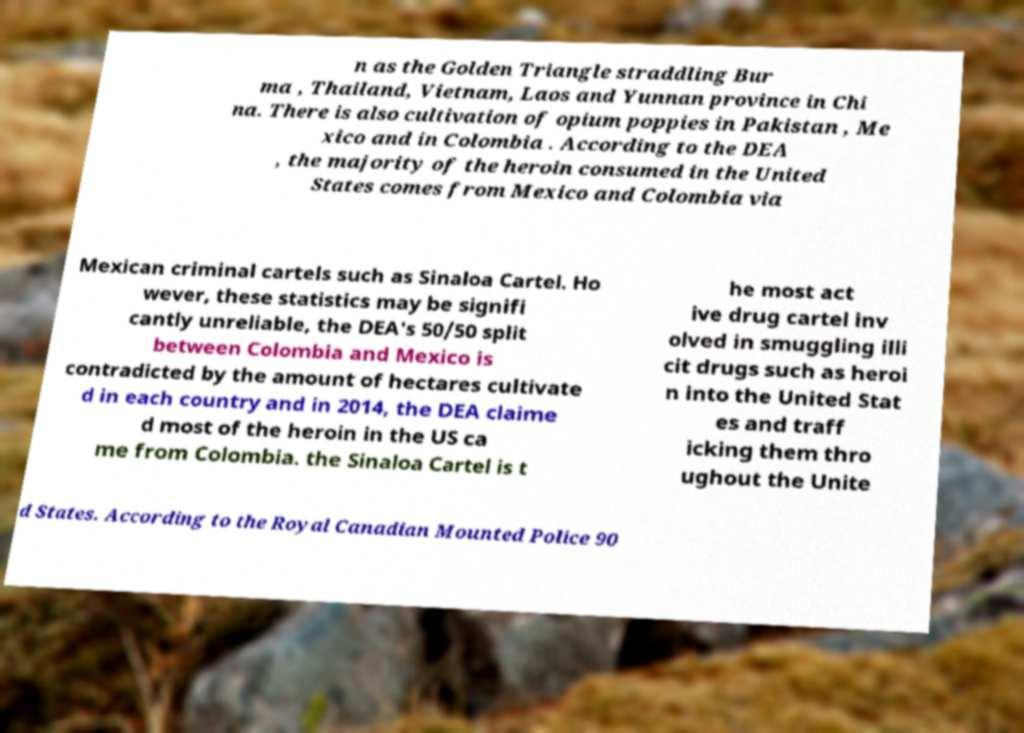Could you extract and type out the text from this image? n as the Golden Triangle straddling Bur ma , Thailand, Vietnam, Laos and Yunnan province in Chi na. There is also cultivation of opium poppies in Pakistan , Me xico and in Colombia . According to the DEA , the majority of the heroin consumed in the United States comes from Mexico and Colombia via Mexican criminal cartels such as Sinaloa Cartel. Ho wever, these statistics may be signifi cantly unreliable, the DEA's 50/50 split between Colombia and Mexico is contradicted by the amount of hectares cultivate d in each country and in 2014, the DEA claime d most of the heroin in the US ca me from Colombia. the Sinaloa Cartel is t he most act ive drug cartel inv olved in smuggling illi cit drugs such as heroi n into the United Stat es and traff icking them thro ughout the Unite d States. According to the Royal Canadian Mounted Police 90 